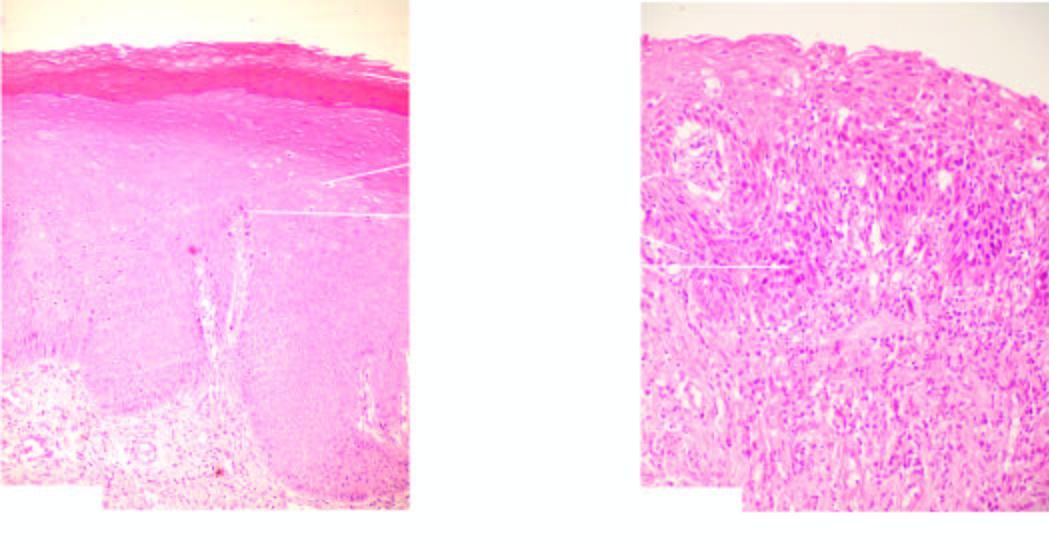s the necrosed area on right side of the field keratosis and orderly arrangement of increased number of layers of stratified mucosa?
Answer the question using a single word or phrase. No 